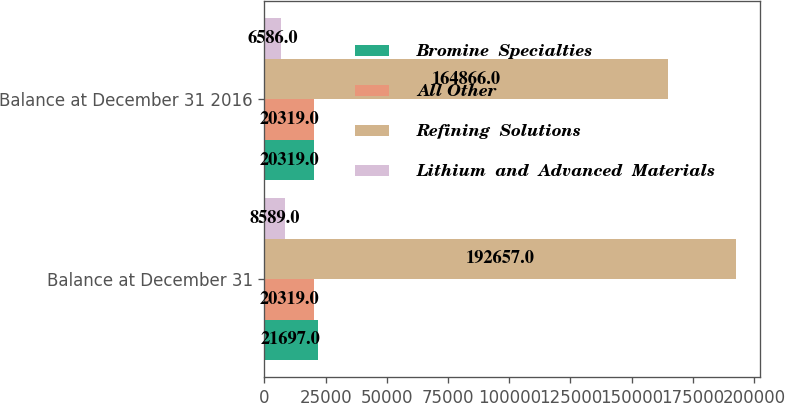Convert chart. <chart><loc_0><loc_0><loc_500><loc_500><stacked_bar_chart><ecel><fcel>Balance at December 31<fcel>Balance at December 31 2016<nl><fcel>Bromine  Specialties<fcel>21697<fcel>20319<nl><fcel>All Other<fcel>20319<fcel>20319<nl><fcel>Refining  Solutions<fcel>192657<fcel>164866<nl><fcel>Lithium  and  Advanced  Materials<fcel>8589<fcel>6586<nl></chart> 